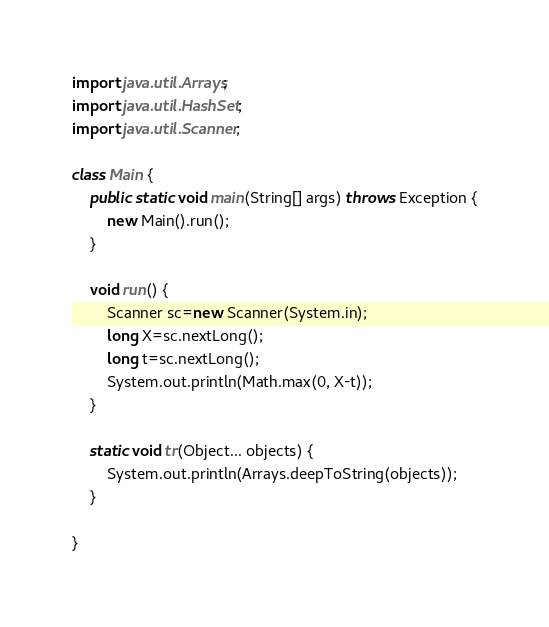Convert code to text. <code><loc_0><loc_0><loc_500><loc_500><_Java_>import java.util.Arrays;
import java.util.HashSet;
import java.util.Scanner;

class Main {
	public static void main(String[] args) throws Exception {
		new Main().run();
	}
	
	void run() {
		Scanner sc=new Scanner(System.in);
		long X=sc.nextLong();
		long t=sc.nextLong();
		System.out.println(Math.max(0, X-t));
	}
	
	static void tr(Object... objects) {
		System.out.println(Arrays.deepToString(objects));
	}
	
}
</code> 